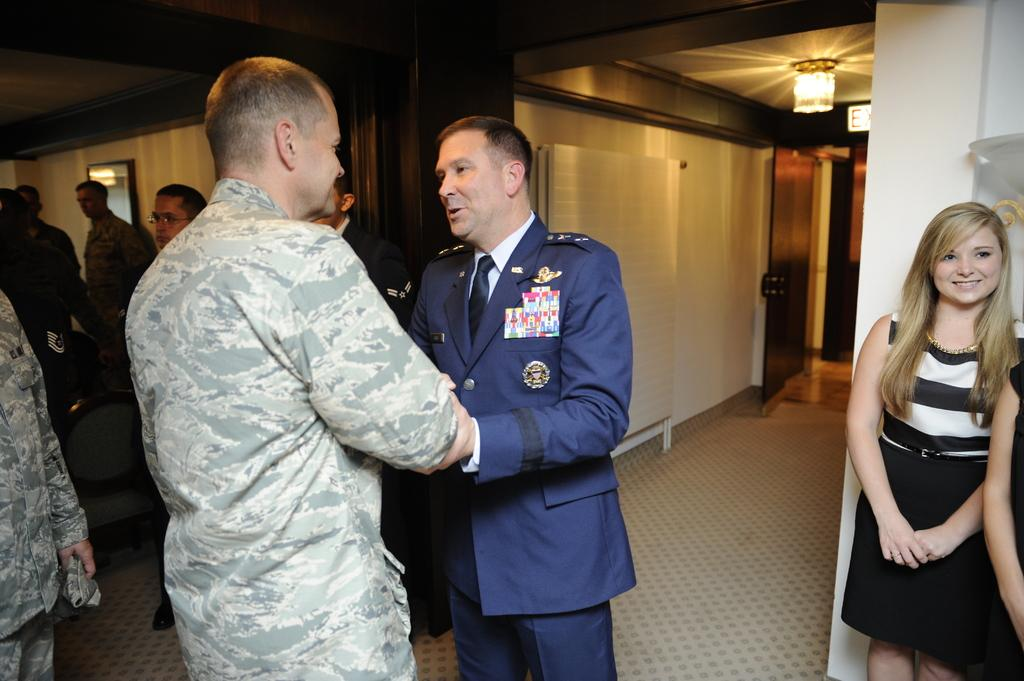What types of people are in the image? There are men and women in the image. What are the men and women doing in the image? The men and women are standing. What can be seen in the background of the image? There is a wall in the image. What is the source of illumination in the image? There is light in the image. What type of square is being used to drink juice in the image? There is no square or juice present in the image. 